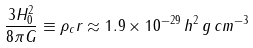<formula> <loc_0><loc_0><loc_500><loc_500>\frac { 3 H _ { 0 } ^ { 2 } } { 8 \pi G } \equiv \rho _ { c } r \approx 1 . 9 \times 1 0 ^ { - 2 9 } \, h ^ { 2 } \, g \, c m ^ { - 3 }</formula> 